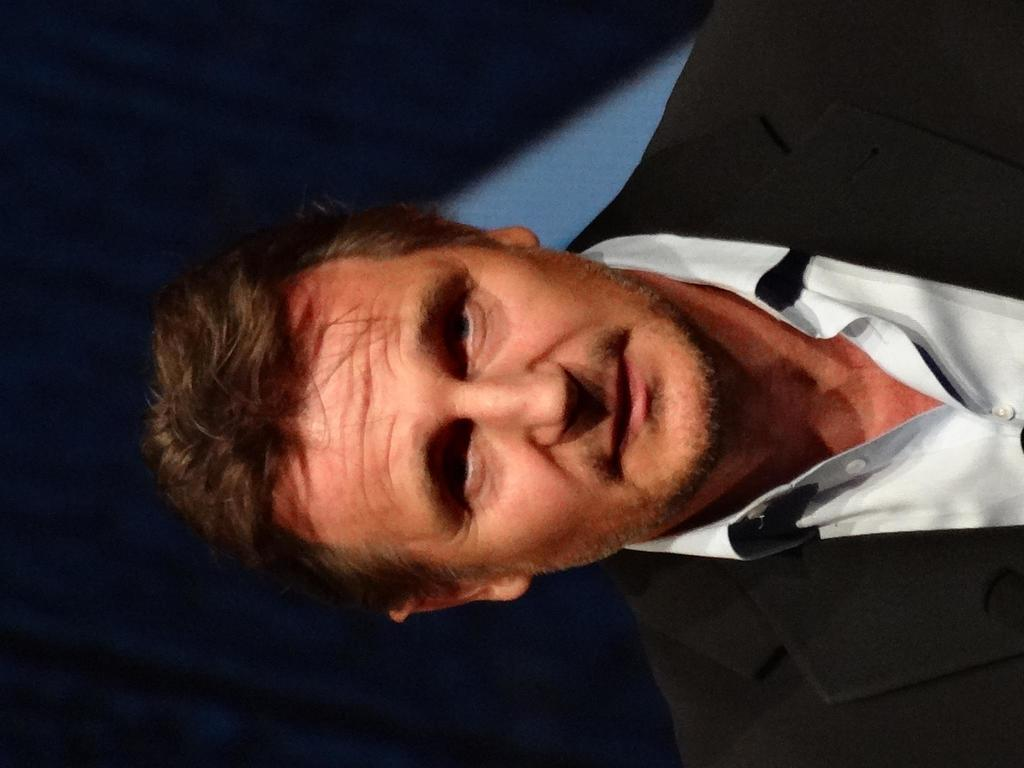Who is present in the image? There is a man in the image. What is the man wearing? The man is wearing a blazer. What is the man's facial expression? The man is smiling. What can be seen in the background of the image? There is a curtain in the background of the image. What is the body of water located in the downtown area in the image? There is no body of water or downtown area present in the image; it features a man wearing a blazer and smiling. 